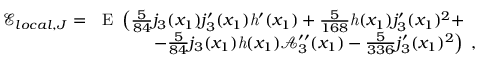Convert formula to latex. <formula><loc_0><loc_0><loc_500><loc_500>\begin{array} { r l } { \mathcal { E } _ { l o c a l , J } = } & { E \ \left ( \frac { 5 } { 8 4 } j _ { 3 } ( x _ { 1 } ) j _ { 3 } ^ { \prime } ( x _ { 1 } ) h ^ { \prime } ( x _ { 1 } ) + \frac { 5 } { 1 6 8 } h ( x _ { 1 } ) j _ { 3 } ^ { \prime } ( x _ { 1 } ) ^ { 2 } + } \\ & { \quad \ - \frac { 5 } { 8 4 } j _ { 3 } ( x _ { 1 } ) h ( x _ { 1 } ) \mathcal { A } _ { 3 } ^ { \prime \prime } ( x _ { 1 } ) - \frac { 5 } { 3 3 6 } j _ { 3 } ^ { \prime } ( x _ { 1 } ) ^ { 2 } \right ) \ , } \end{array}</formula> 